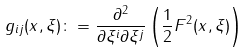Convert formula to latex. <formula><loc_0><loc_0><loc_500><loc_500>g _ { i j } ( x , \xi ) \colon = \frac { \partial ^ { 2 } } { \partial \xi ^ { i } \partial \xi ^ { j } } \left ( \frac { 1 } { 2 } F ^ { 2 } ( x , \xi ) \right )</formula> 